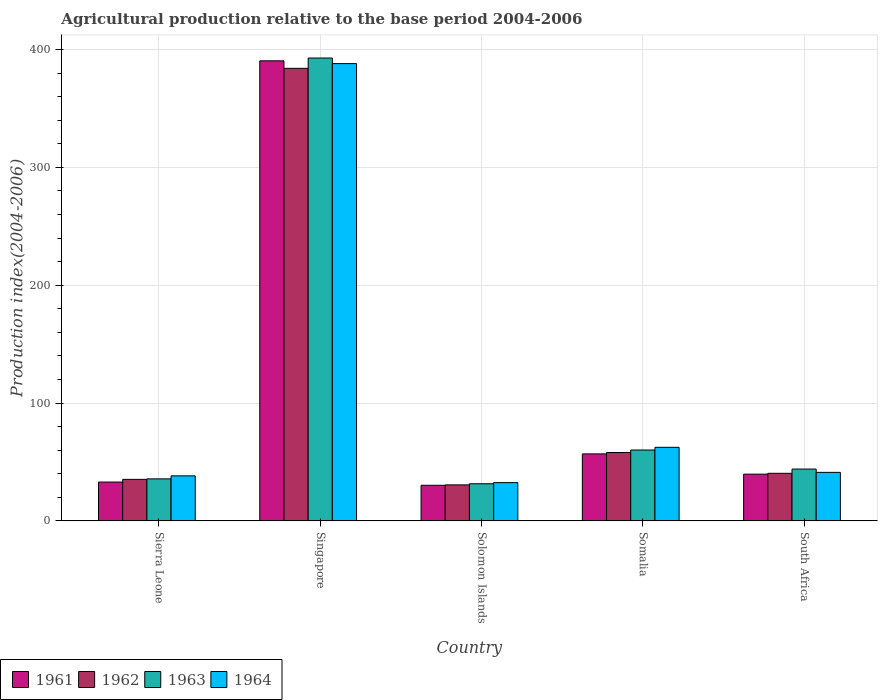How many groups of bars are there?
Offer a very short reply. 5. Are the number of bars on each tick of the X-axis equal?
Give a very brief answer. Yes. How many bars are there on the 3rd tick from the right?
Offer a terse response. 4. What is the label of the 2nd group of bars from the left?
Ensure brevity in your answer.  Singapore. In how many cases, is the number of bars for a given country not equal to the number of legend labels?
Your answer should be very brief. 0. What is the agricultural production index in 1961 in Singapore?
Your answer should be very brief. 390.47. Across all countries, what is the maximum agricultural production index in 1961?
Ensure brevity in your answer.  390.47. Across all countries, what is the minimum agricultural production index in 1963?
Offer a terse response. 31.47. In which country was the agricultural production index in 1962 maximum?
Your answer should be very brief. Singapore. In which country was the agricultural production index in 1963 minimum?
Offer a very short reply. Solomon Islands. What is the total agricultural production index in 1964 in the graph?
Keep it short and to the point. 562.27. What is the difference between the agricultural production index in 1964 in Somalia and that in South Africa?
Keep it short and to the point. 21.27. What is the difference between the agricultural production index in 1962 in Singapore and the agricultural production index in 1961 in Somalia?
Provide a short and direct response. 327.27. What is the average agricultural production index in 1962 per country?
Offer a terse response. 109.63. What is the difference between the agricultural production index of/in 1963 and agricultural production index of/in 1962 in Somalia?
Offer a terse response. 2.12. In how many countries, is the agricultural production index in 1962 greater than 180?
Make the answer very short. 1. What is the ratio of the agricultural production index in 1963 in Sierra Leone to that in Singapore?
Provide a succinct answer. 0.09. Is the agricultural production index in 1962 in Sierra Leone less than that in Somalia?
Provide a succinct answer. Yes. What is the difference between the highest and the second highest agricultural production index in 1962?
Provide a short and direct response. 326.09. What is the difference between the highest and the lowest agricultural production index in 1962?
Give a very brief answer. 353.58. In how many countries, is the agricultural production index in 1961 greater than the average agricultural production index in 1961 taken over all countries?
Provide a short and direct response. 1. Is it the case that in every country, the sum of the agricultural production index in 1961 and agricultural production index in 1963 is greater than the sum of agricultural production index in 1962 and agricultural production index in 1964?
Make the answer very short. No. What does the 1st bar from the right in Solomon Islands represents?
Provide a short and direct response. 1964. How many bars are there?
Give a very brief answer. 20. Are all the bars in the graph horizontal?
Give a very brief answer. No. How many countries are there in the graph?
Give a very brief answer. 5. Are the values on the major ticks of Y-axis written in scientific E-notation?
Provide a succinct answer. No. Does the graph contain any zero values?
Provide a succinct answer. No. Does the graph contain grids?
Your answer should be compact. Yes. How many legend labels are there?
Your response must be concise. 4. What is the title of the graph?
Your response must be concise. Agricultural production relative to the base period 2004-2006. What is the label or title of the X-axis?
Give a very brief answer. Country. What is the label or title of the Y-axis?
Keep it short and to the point. Production index(2004-2006). What is the Production index(2004-2006) of 1961 in Sierra Leone?
Give a very brief answer. 32.91. What is the Production index(2004-2006) of 1962 in Sierra Leone?
Make the answer very short. 35.19. What is the Production index(2004-2006) of 1963 in Sierra Leone?
Ensure brevity in your answer.  35.62. What is the Production index(2004-2006) in 1964 in Sierra Leone?
Your answer should be compact. 38.18. What is the Production index(2004-2006) of 1961 in Singapore?
Ensure brevity in your answer.  390.47. What is the Production index(2004-2006) in 1962 in Singapore?
Offer a terse response. 384.09. What is the Production index(2004-2006) of 1963 in Singapore?
Provide a succinct answer. 392.86. What is the Production index(2004-2006) of 1964 in Singapore?
Offer a very short reply. 388.12. What is the Production index(2004-2006) of 1961 in Solomon Islands?
Offer a terse response. 30.18. What is the Production index(2004-2006) of 1962 in Solomon Islands?
Your answer should be very brief. 30.51. What is the Production index(2004-2006) of 1963 in Solomon Islands?
Give a very brief answer. 31.47. What is the Production index(2004-2006) in 1964 in Solomon Islands?
Make the answer very short. 32.42. What is the Production index(2004-2006) of 1961 in Somalia?
Ensure brevity in your answer.  56.82. What is the Production index(2004-2006) of 1963 in Somalia?
Ensure brevity in your answer.  60.12. What is the Production index(2004-2006) in 1964 in Somalia?
Keep it short and to the point. 62.41. What is the Production index(2004-2006) in 1961 in South Africa?
Give a very brief answer. 39.63. What is the Production index(2004-2006) in 1962 in South Africa?
Give a very brief answer. 40.34. What is the Production index(2004-2006) in 1963 in South Africa?
Provide a short and direct response. 43.95. What is the Production index(2004-2006) of 1964 in South Africa?
Your response must be concise. 41.14. Across all countries, what is the maximum Production index(2004-2006) in 1961?
Give a very brief answer. 390.47. Across all countries, what is the maximum Production index(2004-2006) of 1962?
Ensure brevity in your answer.  384.09. Across all countries, what is the maximum Production index(2004-2006) of 1963?
Keep it short and to the point. 392.86. Across all countries, what is the maximum Production index(2004-2006) in 1964?
Ensure brevity in your answer.  388.12. Across all countries, what is the minimum Production index(2004-2006) in 1961?
Keep it short and to the point. 30.18. Across all countries, what is the minimum Production index(2004-2006) in 1962?
Keep it short and to the point. 30.51. Across all countries, what is the minimum Production index(2004-2006) in 1963?
Provide a short and direct response. 31.47. Across all countries, what is the minimum Production index(2004-2006) of 1964?
Give a very brief answer. 32.42. What is the total Production index(2004-2006) of 1961 in the graph?
Offer a terse response. 550.01. What is the total Production index(2004-2006) in 1962 in the graph?
Provide a short and direct response. 548.13. What is the total Production index(2004-2006) of 1963 in the graph?
Your answer should be compact. 564.02. What is the total Production index(2004-2006) of 1964 in the graph?
Give a very brief answer. 562.27. What is the difference between the Production index(2004-2006) of 1961 in Sierra Leone and that in Singapore?
Give a very brief answer. -357.56. What is the difference between the Production index(2004-2006) in 1962 in Sierra Leone and that in Singapore?
Your response must be concise. -348.9. What is the difference between the Production index(2004-2006) of 1963 in Sierra Leone and that in Singapore?
Your response must be concise. -357.24. What is the difference between the Production index(2004-2006) in 1964 in Sierra Leone and that in Singapore?
Your answer should be very brief. -349.94. What is the difference between the Production index(2004-2006) of 1961 in Sierra Leone and that in Solomon Islands?
Provide a succinct answer. 2.73. What is the difference between the Production index(2004-2006) of 1962 in Sierra Leone and that in Solomon Islands?
Your answer should be compact. 4.68. What is the difference between the Production index(2004-2006) in 1963 in Sierra Leone and that in Solomon Islands?
Provide a succinct answer. 4.15. What is the difference between the Production index(2004-2006) in 1964 in Sierra Leone and that in Solomon Islands?
Offer a very short reply. 5.76. What is the difference between the Production index(2004-2006) of 1961 in Sierra Leone and that in Somalia?
Offer a terse response. -23.91. What is the difference between the Production index(2004-2006) in 1962 in Sierra Leone and that in Somalia?
Provide a short and direct response. -22.81. What is the difference between the Production index(2004-2006) of 1963 in Sierra Leone and that in Somalia?
Give a very brief answer. -24.5. What is the difference between the Production index(2004-2006) of 1964 in Sierra Leone and that in Somalia?
Provide a short and direct response. -24.23. What is the difference between the Production index(2004-2006) in 1961 in Sierra Leone and that in South Africa?
Give a very brief answer. -6.72. What is the difference between the Production index(2004-2006) of 1962 in Sierra Leone and that in South Africa?
Provide a short and direct response. -5.15. What is the difference between the Production index(2004-2006) of 1963 in Sierra Leone and that in South Africa?
Your answer should be compact. -8.33. What is the difference between the Production index(2004-2006) of 1964 in Sierra Leone and that in South Africa?
Offer a very short reply. -2.96. What is the difference between the Production index(2004-2006) in 1961 in Singapore and that in Solomon Islands?
Make the answer very short. 360.29. What is the difference between the Production index(2004-2006) of 1962 in Singapore and that in Solomon Islands?
Ensure brevity in your answer.  353.58. What is the difference between the Production index(2004-2006) of 1963 in Singapore and that in Solomon Islands?
Give a very brief answer. 361.39. What is the difference between the Production index(2004-2006) of 1964 in Singapore and that in Solomon Islands?
Provide a short and direct response. 355.7. What is the difference between the Production index(2004-2006) of 1961 in Singapore and that in Somalia?
Give a very brief answer. 333.65. What is the difference between the Production index(2004-2006) of 1962 in Singapore and that in Somalia?
Your answer should be very brief. 326.09. What is the difference between the Production index(2004-2006) in 1963 in Singapore and that in Somalia?
Offer a very short reply. 332.74. What is the difference between the Production index(2004-2006) in 1964 in Singapore and that in Somalia?
Offer a terse response. 325.71. What is the difference between the Production index(2004-2006) of 1961 in Singapore and that in South Africa?
Your response must be concise. 350.84. What is the difference between the Production index(2004-2006) in 1962 in Singapore and that in South Africa?
Your answer should be compact. 343.75. What is the difference between the Production index(2004-2006) in 1963 in Singapore and that in South Africa?
Offer a terse response. 348.91. What is the difference between the Production index(2004-2006) in 1964 in Singapore and that in South Africa?
Your response must be concise. 346.98. What is the difference between the Production index(2004-2006) in 1961 in Solomon Islands and that in Somalia?
Your answer should be compact. -26.64. What is the difference between the Production index(2004-2006) in 1962 in Solomon Islands and that in Somalia?
Ensure brevity in your answer.  -27.49. What is the difference between the Production index(2004-2006) in 1963 in Solomon Islands and that in Somalia?
Your answer should be compact. -28.65. What is the difference between the Production index(2004-2006) of 1964 in Solomon Islands and that in Somalia?
Give a very brief answer. -29.99. What is the difference between the Production index(2004-2006) in 1961 in Solomon Islands and that in South Africa?
Your response must be concise. -9.45. What is the difference between the Production index(2004-2006) of 1962 in Solomon Islands and that in South Africa?
Make the answer very short. -9.83. What is the difference between the Production index(2004-2006) in 1963 in Solomon Islands and that in South Africa?
Make the answer very short. -12.48. What is the difference between the Production index(2004-2006) of 1964 in Solomon Islands and that in South Africa?
Offer a very short reply. -8.72. What is the difference between the Production index(2004-2006) in 1961 in Somalia and that in South Africa?
Provide a succinct answer. 17.19. What is the difference between the Production index(2004-2006) in 1962 in Somalia and that in South Africa?
Offer a terse response. 17.66. What is the difference between the Production index(2004-2006) of 1963 in Somalia and that in South Africa?
Keep it short and to the point. 16.17. What is the difference between the Production index(2004-2006) of 1964 in Somalia and that in South Africa?
Your response must be concise. 21.27. What is the difference between the Production index(2004-2006) in 1961 in Sierra Leone and the Production index(2004-2006) in 1962 in Singapore?
Your answer should be compact. -351.18. What is the difference between the Production index(2004-2006) in 1961 in Sierra Leone and the Production index(2004-2006) in 1963 in Singapore?
Give a very brief answer. -359.95. What is the difference between the Production index(2004-2006) in 1961 in Sierra Leone and the Production index(2004-2006) in 1964 in Singapore?
Give a very brief answer. -355.21. What is the difference between the Production index(2004-2006) in 1962 in Sierra Leone and the Production index(2004-2006) in 1963 in Singapore?
Your answer should be compact. -357.67. What is the difference between the Production index(2004-2006) of 1962 in Sierra Leone and the Production index(2004-2006) of 1964 in Singapore?
Provide a short and direct response. -352.93. What is the difference between the Production index(2004-2006) in 1963 in Sierra Leone and the Production index(2004-2006) in 1964 in Singapore?
Keep it short and to the point. -352.5. What is the difference between the Production index(2004-2006) of 1961 in Sierra Leone and the Production index(2004-2006) of 1963 in Solomon Islands?
Your answer should be very brief. 1.44. What is the difference between the Production index(2004-2006) in 1961 in Sierra Leone and the Production index(2004-2006) in 1964 in Solomon Islands?
Your response must be concise. 0.49. What is the difference between the Production index(2004-2006) of 1962 in Sierra Leone and the Production index(2004-2006) of 1963 in Solomon Islands?
Ensure brevity in your answer.  3.72. What is the difference between the Production index(2004-2006) of 1962 in Sierra Leone and the Production index(2004-2006) of 1964 in Solomon Islands?
Keep it short and to the point. 2.77. What is the difference between the Production index(2004-2006) of 1963 in Sierra Leone and the Production index(2004-2006) of 1964 in Solomon Islands?
Provide a succinct answer. 3.2. What is the difference between the Production index(2004-2006) of 1961 in Sierra Leone and the Production index(2004-2006) of 1962 in Somalia?
Offer a very short reply. -25.09. What is the difference between the Production index(2004-2006) of 1961 in Sierra Leone and the Production index(2004-2006) of 1963 in Somalia?
Ensure brevity in your answer.  -27.21. What is the difference between the Production index(2004-2006) in 1961 in Sierra Leone and the Production index(2004-2006) in 1964 in Somalia?
Make the answer very short. -29.5. What is the difference between the Production index(2004-2006) in 1962 in Sierra Leone and the Production index(2004-2006) in 1963 in Somalia?
Give a very brief answer. -24.93. What is the difference between the Production index(2004-2006) in 1962 in Sierra Leone and the Production index(2004-2006) in 1964 in Somalia?
Give a very brief answer. -27.22. What is the difference between the Production index(2004-2006) in 1963 in Sierra Leone and the Production index(2004-2006) in 1964 in Somalia?
Your response must be concise. -26.79. What is the difference between the Production index(2004-2006) in 1961 in Sierra Leone and the Production index(2004-2006) in 1962 in South Africa?
Offer a very short reply. -7.43. What is the difference between the Production index(2004-2006) in 1961 in Sierra Leone and the Production index(2004-2006) in 1963 in South Africa?
Keep it short and to the point. -11.04. What is the difference between the Production index(2004-2006) of 1961 in Sierra Leone and the Production index(2004-2006) of 1964 in South Africa?
Offer a very short reply. -8.23. What is the difference between the Production index(2004-2006) of 1962 in Sierra Leone and the Production index(2004-2006) of 1963 in South Africa?
Ensure brevity in your answer.  -8.76. What is the difference between the Production index(2004-2006) of 1962 in Sierra Leone and the Production index(2004-2006) of 1964 in South Africa?
Ensure brevity in your answer.  -5.95. What is the difference between the Production index(2004-2006) in 1963 in Sierra Leone and the Production index(2004-2006) in 1964 in South Africa?
Your answer should be compact. -5.52. What is the difference between the Production index(2004-2006) in 1961 in Singapore and the Production index(2004-2006) in 1962 in Solomon Islands?
Offer a terse response. 359.96. What is the difference between the Production index(2004-2006) of 1961 in Singapore and the Production index(2004-2006) of 1963 in Solomon Islands?
Give a very brief answer. 359. What is the difference between the Production index(2004-2006) of 1961 in Singapore and the Production index(2004-2006) of 1964 in Solomon Islands?
Keep it short and to the point. 358.05. What is the difference between the Production index(2004-2006) of 1962 in Singapore and the Production index(2004-2006) of 1963 in Solomon Islands?
Keep it short and to the point. 352.62. What is the difference between the Production index(2004-2006) in 1962 in Singapore and the Production index(2004-2006) in 1964 in Solomon Islands?
Make the answer very short. 351.67. What is the difference between the Production index(2004-2006) in 1963 in Singapore and the Production index(2004-2006) in 1964 in Solomon Islands?
Your answer should be very brief. 360.44. What is the difference between the Production index(2004-2006) of 1961 in Singapore and the Production index(2004-2006) of 1962 in Somalia?
Offer a terse response. 332.47. What is the difference between the Production index(2004-2006) of 1961 in Singapore and the Production index(2004-2006) of 1963 in Somalia?
Provide a short and direct response. 330.35. What is the difference between the Production index(2004-2006) of 1961 in Singapore and the Production index(2004-2006) of 1964 in Somalia?
Provide a short and direct response. 328.06. What is the difference between the Production index(2004-2006) in 1962 in Singapore and the Production index(2004-2006) in 1963 in Somalia?
Your answer should be very brief. 323.97. What is the difference between the Production index(2004-2006) of 1962 in Singapore and the Production index(2004-2006) of 1964 in Somalia?
Offer a very short reply. 321.68. What is the difference between the Production index(2004-2006) in 1963 in Singapore and the Production index(2004-2006) in 1964 in Somalia?
Your answer should be compact. 330.45. What is the difference between the Production index(2004-2006) of 1961 in Singapore and the Production index(2004-2006) of 1962 in South Africa?
Offer a very short reply. 350.13. What is the difference between the Production index(2004-2006) in 1961 in Singapore and the Production index(2004-2006) in 1963 in South Africa?
Give a very brief answer. 346.52. What is the difference between the Production index(2004-2006) in 1961 in Singapore and the Production index(2004-2006) in 1964 in South Africa?
Provide a short and direct response. 349.33. What is the difference between the Production index(2004-2006) of 1962 in Singapore and the Production index(2004-2006) of 1963 in South Africa?
Your response must be concise. 340.14. What is the difference between the Production index(2004-2006) of 1962 in Singapore and the Production index(2004-2006) of 1964 in South Africa?
Provide a succinct answer. 342.95. What is the difference between the Production index(2004-2006) in 1963 in Singapore and the Production index(2004-2006) in 1964 in South Africa?
Your response must be concise. 351.72. What is the difference between the Production index(2004-2006) in 1961 in Solomon Islands and the Production index(2004-2006) in 1962 in Somalia?
Make the answer very short. -27.82. What is the difference between the Production index(2004-2006) of 1961 in Solomon Islands and the Production index(2004-2006) of 1963 in Somalia?
Ensure brevity in your answer.  -29.94. What is the difference between the Production index(2004-2006) in 1961 in Solomon Islands and the Production index(2004-2006) in 1964 in Somalia?
Your answer should be compact. -32.23. What is the difference between the Production index(2004-2006) of 1962 in Solomon Islands and the Production index(2004-2006) of 1963 in Somalia?
Give a very brief answer. -29.61. What is the difference between the Production index(2004-2006) in 1962 in Solomon Islands and the Production index(2004-2006) in 1964 in Somalia?
Give a very brief answer. -31.9. What is the difference between the Production index(2004-2006) in 1963 in Solomon Islands and the Production index(2004-2006) in 1964 in Somalia?
Provide a succinct answer. -30.94. What is the difference between the Production index(2004-2006) of 1961 in Solomon Islands and the Production index(2004-2006) of 1962 in South Africa?
Ensure brevity in your answer.  -10.16. What is the difference between the Production index(2004-2006) of 1961 in Solomon Islands and the Production index(2004-2006) of 1963 in South Africa?
Make the answer very short. -13.77. What is the difference between the Production index(2004-2006) of 1961 in Solomon Islands and the Production index(2004-2006) of 1964 in South Africa?
Make the answer very short. -10.96. What is the difference between the Production index(2004-2006) of 1962 in Solomon Islands and the Production index(2004-2006) of 1963 in South Africa?
Make the answer very short. -13.44. What is the difference between the Production index(2004-2006) in 1962 in Solomon Islands and the Production index(2004-2006) in 1964 in South Africa?
Your answer should be compact. -10.63. What is the difference between the Production index(2004-2006) in 1963 in Solomon Islands and the Production index(2004-2006) in 1964 in South Africa?
Offer a very short reply. -9.67. What is the difference between the Production index(2004-2006) in 1961 in Somalia and the Production index(2004-2006) in 1962 in South Africa?
Your response must be concise. 16.48. What is the difference between the Production index(2004-2006) in 1961 in Somalia and the Production index(2004-2006) in 1963 in South Africa?
Provide a succinct answer. 12.87. What is the difference between the Production index(2004-2006) of 1961 in Somalia and the Production index(2004-2006) of 1964 in South Africa?
Ensure brevity in your answer.  15.68. What is the difference between the Production index(2004-2006) of 1962 in Somalia and the Production index(2004-2006) of 1963 in South Africa?
Give a very brief answer. 14.05. What is the difference between the Production index(2004-2006) in 1962 in Somalia and the Production index(2004-2006) in 1964 in South Africa?
Provide a short and direct response. 16.86. What is the difference between the Production index(2004-2006) of 1963 in Somalia and the Production index(2004-2006) of 1964 in South Africa?
Provide a short and direct response. 18.98. What is the average Production index(2004-2006) in 1961 per country?
Give a very brief answer. 110. What is the average Production index(2004-2006) in 1962 per country?
Give a very brief answer. 109.63. What is the average Production index(2004-2006) of 1963 per country?
Offer a very short reply. 112.8. What is the average Production index(2004-2006) of 1964 per country?
Your response must be concise. 112.45. What is the difference between the Production index(2004-2006) of 1961 and Production index(2004-2006) of 1962 in Sierra Leone?
Keep it short and to the point. -2.28. What is the difference between the Production index(2004-2006) in 1961 and Production index(2004-2006) in 1963 in Sierra Leone?
Ensure brevity in your answer.  -2.71. What is the difference between the Production index(2004-2006) in 1961 and Production index(2004-2006) in 1964 in Sierra Leone?
Keep it short and to the point. -5.27. What is the difference between the Production index(2004-2006) in 1962 and Production index(2004-2006) in 1963 in Sierra Leone?
Provide a succinct answer. -0.43. What is the difference between the Production index(2004-2006) of 1962 and Production index(2004-2006) of 1964 in Sierra Leone?
Offer a terse response. -2.99. What is the difference between the Production index(2004-2006) in 1963 and Production index(2004-2006) in 1964 in Sierra Leone?
Your answer should be compact. -2.56. What is the difference between the Production index(2004-2006) in 1961 and Production index(2004-2006) in 1962 in Singapore?
Ensure brevity in your answer.  6.38. What is the difference between the Production index(2004-2006) in 1961 and Production index(2004-2006) in 1963 in Singapore?
Make the answer very short. -2.39. What is the difference between the Production index(2004-2006) in 1961 and Production index(2004-2006) in 1964 in Singapore?
Your answer should be very brief. 2.35. What is the difference between the Production index(2004-2006) of 1962 and Production index(2004-2006) of 1963 in Singapore?
Keep it short and to the point. -8.77. What is the difference between the Production index(2004-2006) of 1962 and Production index(2004-2006) of 1964 in Singapore?
Provide a short and direct response. -4.03. What is the difference between the Production index(2004-2006) in 1963 and Production index(2004-2006) in 1964 in Singapore?
Provide a succinct answer. 4.74. What is the difference between the Production index(2004-2006) of 1961 and Production index(2004-2006) of 1962 in Solomon Islands?
Your answer should be compact. -0.33. What is the difference between the Production index(2004-2006) of 1961 and Production index(2004-2006) of 1963 in Solomon Islands?
Offer a very short reply. -1.29. What is the difference between the Production index(2004-2006) of 1961 and Production index(2004-2006) of 1964 in Solomon Islands?
Your response must be concise. -2.24. What is the difference between the Production index(2004-2006) in 1962 and Production index(2004-2006) in 1963 in Solomon Islands?
Your response must be concise. -0.96. What is the difference between the Production index(2004-2006) in 1962 and Production index(2004-2006) in 1964 in Solomon Islands?
Offer a terse response. -1.91. What is the difference between the Production index(2004-2006) of 1963 and Production index(2004-2006) of 1964 in Solomon Islands?
Give a very brief answer. -0.95. What is the difference between the Production index(2004-2006) of 1961 and Production index(2004-2006) of 1962 in Somalia?
Provide a short and direct response. -1.18. What is the difference between the Production index(2004-2006) in 1961 and Production index(2004-2006) in 1963 in Somalia?
Your response must be concise. -3.3. What is the difference between the Production index(2004-2006) of 1961 and Production index(2004-2006) of 1964 in Somalia?
Make the answer very short. -5.59. What is the difference between the Production index(2004-2006) in 1962 and Production index(2004-2006) in 1963 in Somalia?
Offer a terse response. -2.12. What is the difference between the Production index(2004-2006) in 1962 and Production index(2004-2006) in 1964 in Somalia?
Offer a terse response. -4.41. What is the difference between the Production index(2004-2006) in 1963 and Production index(2004-2006) in 1964 in Somalia?
Give a very brief answer. -2.29. What is the difference between the Production index(2004-2006) in 1961 and Production index(2004-2006) in 1962 in South Africa?
Provide a succinct answer. -0.71. What is the difference between the Production index(2004-2006) in 1961 and Production index(2004-2006) in 1963 in South Africa?
Your response must be concise. -4.32. What is the difference between the Production index(2004-2006) in 1961 and Production index(2004-2006) in 1964 in South Africa?
Offer a very short reply. -1.51. What is the difference between the Production index(2004-2006) in 1962 and Production index(2004-2006) in 1963 in South Africa?
Offer a terse response. -3.61. What is the difference between the Production index(2004-2006) in 1962 and Production index(2004-2006) in 1964 in South Africa?
Offer a terse response. -0.8. What is the difference between the Production index(2004-2006) in 1963 and Production index(2004-2006) in 1964 in South Africa?
Your answer should be very brief. 2.81. What is the ratio of the Production index(2004-2006) in 1961 in Sierra Leone to that in Singapore?
Provide a short and direct response. 0.08. What is the ratio of the Production index(2004-2006) of 1962 in Sierra Leone to that in Singapore?
Ensure brevity in your answer.  0.09. What is the ratio of the Production index(2004-2006) in 1963 in Sierra Leone to that in Singapore?
Ensure brevity in your answer.  0.09. What is the ratio of the Production index(2004-2006) of 1964 in Sierra Leone to that in Singapore?
Your response must be concise. 0.1. What is the ratio of the Production index(2004-2006) of 1961 in Sierra Leone to that in Solomon Islands?
Ensure brevity in your answer.  1.09. What is the ratio of the Production index(2004-2006) of 1962 in Sierra Leone to that in Solomon Islands?
Provide a succinct answer. 1.15. What is the ratio of the Production index(2004-2006) in 1963 in Sierra Leone to that in Solomon Islands?
Make the answer very short. 1.13. What is the ratio of the Production index(2004-2006) of 1964 in Sierra Leone to that in Solomon Islands?
Keep it short and to the point. 1.18. What is the ratio of the Production index(2004-2006) in 1961 in Sierra Leone to that in Somalia?
Provide a short and direct response. 0.58. What is the ratio of the Production index(2004-2006) in 1962 in Sierra Leone to that in Somalia?
Provide a short and direct response. 0.61. What is the ratio of the Production index(2004-2006) in 1963 in Sierra Leone to that in Somalia?
Provide a succinct answer. 0.59. What is the ratio of the Production index(2004-2006) of 1964 in Sierra Leone to that in Somalia?
Provide a succinct answer. 0.61. What is the ratio of the Production index(2004-2006) of 1961 in Sierra Leone to that in South Africa?
Keep it short and to the point. 0.83. What is the ratio of the Production index(2004-2006) of 1962 in Sierra Leone to that in South Africa?
Keep it short and to the point. 0.87. What is the ratio of the Production index(2004-2006) in 1963 in Sierra Leone to that in South Africa?
Your response must be concise. 0.81. What is the ratio of the Production index(2004-2006) of 1964 in Sierra Leone to that in South Africa?
Make the answer very short. 0.93. What is the ratio of the Production index(2004-2006) of 1961 in Singapore to that in Solomon Islands?
Your response must be concise. 12.94. What is the ratio of the Production index(2004-2006) in 1962 in Singapore to that in Solomon Islands?
Give a very brief answer. 12.59. What is the ratio of the Production index(2004-2006) of 1963 in Singapore to that in Solomon Islands?
Your answer should be compact. 12.48. What is the ratio of the Production index(2004-2006) in 1964 in Singapore to that in Solomon Islands?
Your answer should be compact. 11.97. What is the ratio of the Production index(2004-2006) of 1961 in Singapore to that in Somalia?
Your answer should be very brief. 6.87. What is the ratio of the Production index(2004-2006) of 1962 in Singapore to that in Somalia?
Make the answer very short. 6.62. What is the ratio of the Production index(2004-2006) in 1963 in Singapore to that in Somalia?
Give a very brief answer. 6.53. What is the ratio of the Production index(2004-2006) of 1964 in Singapore to that in Somalia?
Offer a terse response. 6.22. What is the ratio of the Production index(2004-2006) in 1961 in Singapore to that in South Africa?
Ensure brevity in your answer.  9.85. What is the ratio of the Production index(2004-2006) of 1962 in Singapore to that in South Africa?
Make the answer very short. 9.52. What is the ratio of the Production index(2004-2006) of 1963 in Singapore to that in South Africa?
Your response must be concise. 8.94. What is the ratio of the Production index(2004-2006) in 1964 in Singapore to that in South Africa?
Your answer should be very brief. 9.43. What is the ratio of the Production index(2004-2006) in 1961 in Solomon Islands to that in Somalia?
Keep it short and to the point. 0.53. What is the ratio of the Production index(2004-2006) of 1962 in Solomon Islands to that in Somalia?
Your answer should be very brief. 0.53. What is the ratio of the Production index(2004-2006) of 1963 in Solomon Islands to that in Somalia?
Provide a succinct answer. 0.52. What is the ratio of the Production index(2004-2006) in 1964 in Solomon Islands to that in Somalia?
Provide a succinct answer. 0.52. What is the ratio of the Production index(2004-2006) of 1961 in Solomon Islands to that in South Africa?
Your answer should be compact. 0.76. What is the ratio of the Production index(2004-2006) of 1962 in Solomon Islands to that in South Africa?
Give a very brief answer. 0.76. What is the ratio of the Production index(2004-2006) of 1963 in Solomon Islands to that in South Africa?
Keep it short and to the point. 0.72. What is the ratio of the Production index(2004-2006) of 1964 in Solomon Islands to that in South Africa?
Ensure brevity in your answer.  0.79. What is the ratio of the Production index(2004-2006) of 1961 in Somalia to that in South Africa?
Provide a short and direct response. 1.43. What is the ratio of the Production index(2004-2006) of 1962 in Somalia to that in South Africa?
Provide a short and direct response. 1.44. What is the ratio of the Production index(2004-2006) in 1963 in Somalia to that in South Africa?
Provide a short and direct response. 1.37. What is the ratio of the Production index(2004-2006) of 1964 in Somalia to that in South Africa?
Your response must be concise. 1.52. What is the difference between the highest and the second highest Production index(2004-2006) of 1961?
Your answer should be very brief. 333.65. What is the difference between the highest and the second highest Production index(2004-2006) in 1962?
Your response must be concise. 326.09. What is the difference between the highest and the second highest Production index(2004-2006) of 1963?
Offer a very short reply. 332.74. What is the difference between the highest and the second highest Production index(2004-2006) of 1964?
Offer a very short reply. 325.71. What is the difference between the highest and the lowest Production index(2004-2006) of 1961?
Ensure brevity in your answer.  360.29. What is the difference between the highest and the lowest Production index(2004-2006) in 1962?
Provide a succinct answer. 353.58. What is the difference between the highest and the lowest Production index(2004-2006) of 1963?
Keep it short and to the point. 361.39. What is the difference between the highest and the lowest Production index(2004-2006) in 1964?
Ensure brevity in your answer.  355.7. 